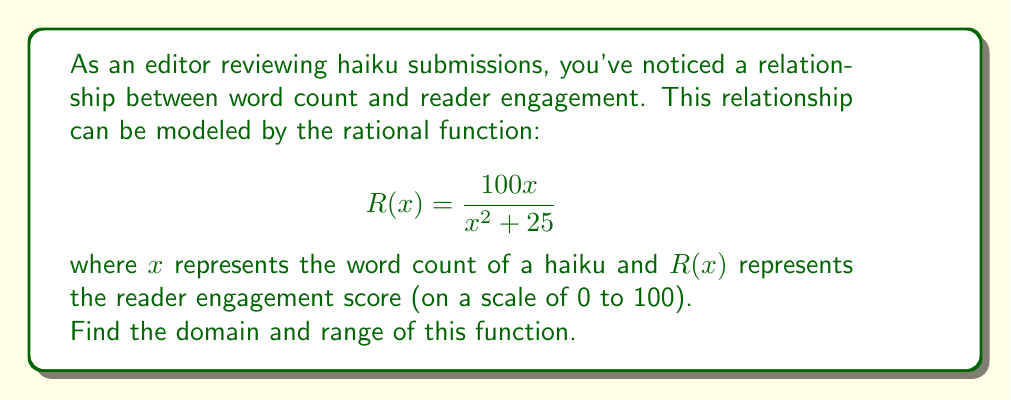Provide a solution to this math problem. To find the domain and range of this rational function, we'll follow these steps:

1. Domain:
   The domain consists of all real numbers for which the function is defined. A rational function is undefined when its denominator equals zero.
   
   Set the denominator to zero and solve:
   $$x^2 + 25 = 0$$
   $$x^2 = -25$$
   
   This equation has no real solutions because a squared number cannot be negative.
   Therefore, the denominator is never zero for any real value of $x$.
   
   The domain is all real numbers: $(-\infty, \infty)$

2. Range:
   To find the range, we'll analyze the behavior of the function:
   
   a) As $x$ approaches $\pm\infty$, $R(x)$ approaches 0:
      $$\lim_{x \to \pm\infty} \frac{100x}{x^2 + 25} = \lim_{x \to \pm\infty} \frac{100}{x + \frac{25}{x}} = 0$$
   
   b) To find the maximum value, we can differentiate $R(x)$ and set it to zero:
      $$R'(x) = \frac{100(x^2 + 25) - 100x(2x)}{(x^2 + 25)^2} = \frac{2500 - 100x^2}{(x^2 + 25)^2}$$
      
      Set $R'(x) = 0$:
      $$2500 - 100x^2 = 0$$
      $$x^2 = 25$$
      $$x = \pm 5$$
      
   c) The maximum value occurs at $x = \pm 5$:
      $$R(5) = R(-5) = \frac{100(5)}{5^2 + 25} = \frac{500}{50} = 10$$

Therefore, the range of the function is $(0, 10]$.
Answer: Domain: $(-\infty, \infty)$; Range: $(0, 10]$ 